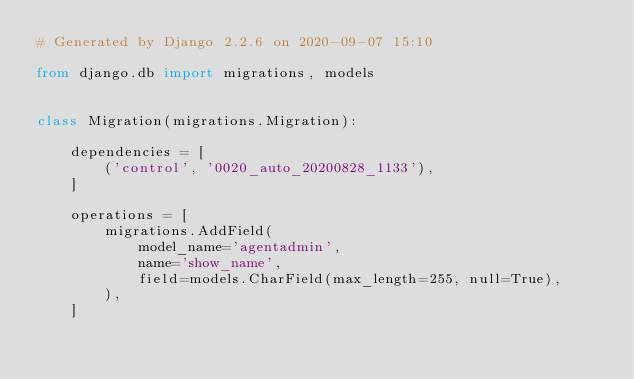Convert code to text. <code><loc_0><loc_0><loc_500><loc_500><_Python_># Generated by Django 2.2.6 on 2020-09-07 15:10

from django.db import migrations, models


class Migration(migrations.Migration):

    dependencies = [
        ('control', '0020_auto_20200828_1133'),
    ]

    operations = [
        migrations.AddField(
            model_name='agentadmin',
            name='show_name',
            field=models.CharField(max_length=255, null=True),
        ),
    ]
</code> 